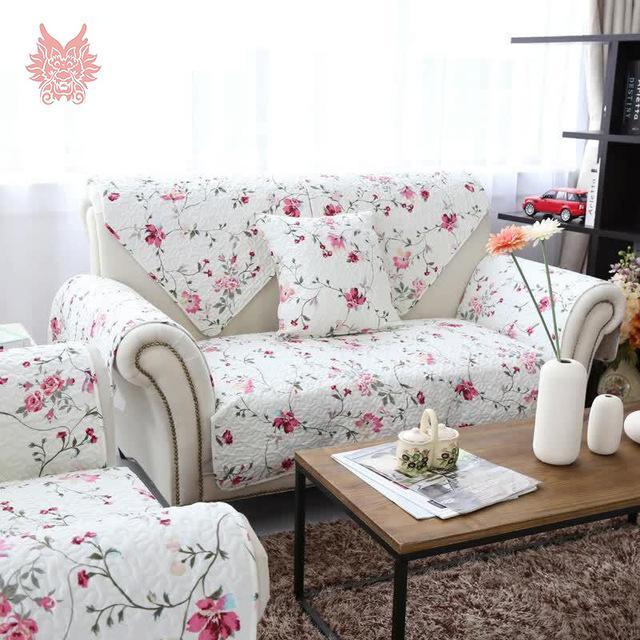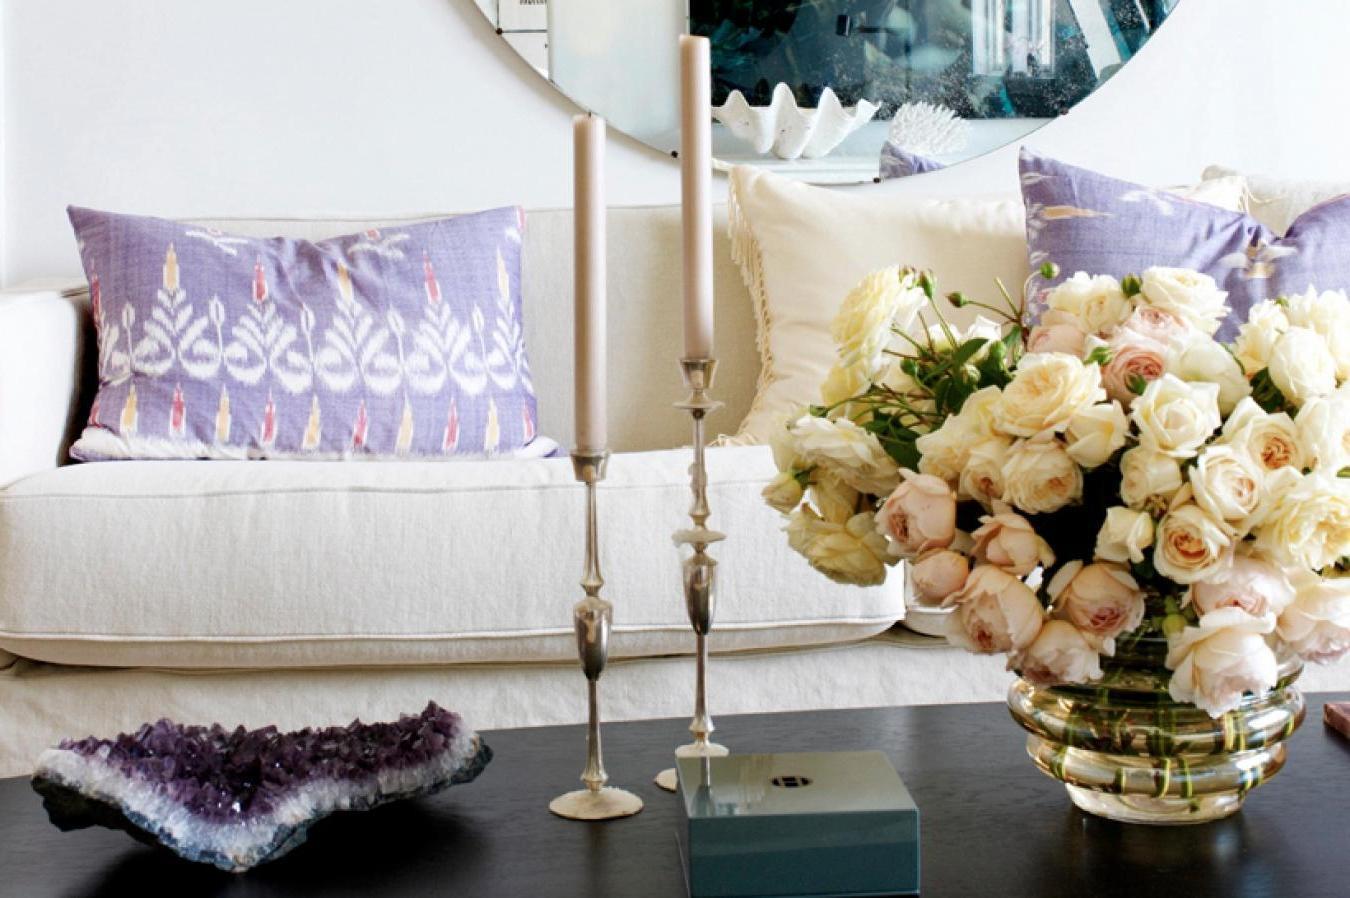The first image is the image on the left, the second image is the image on the right. Considering the images on both sides, is "there are white columns behind a sofa" valid? Answer yes or no. No. The first image is the image on the left, the second image is the image on the right. Examine the images to the left and right. Is the description "The pillows in the left image match the sofa." accurate? Answer yes or no. Yes. 